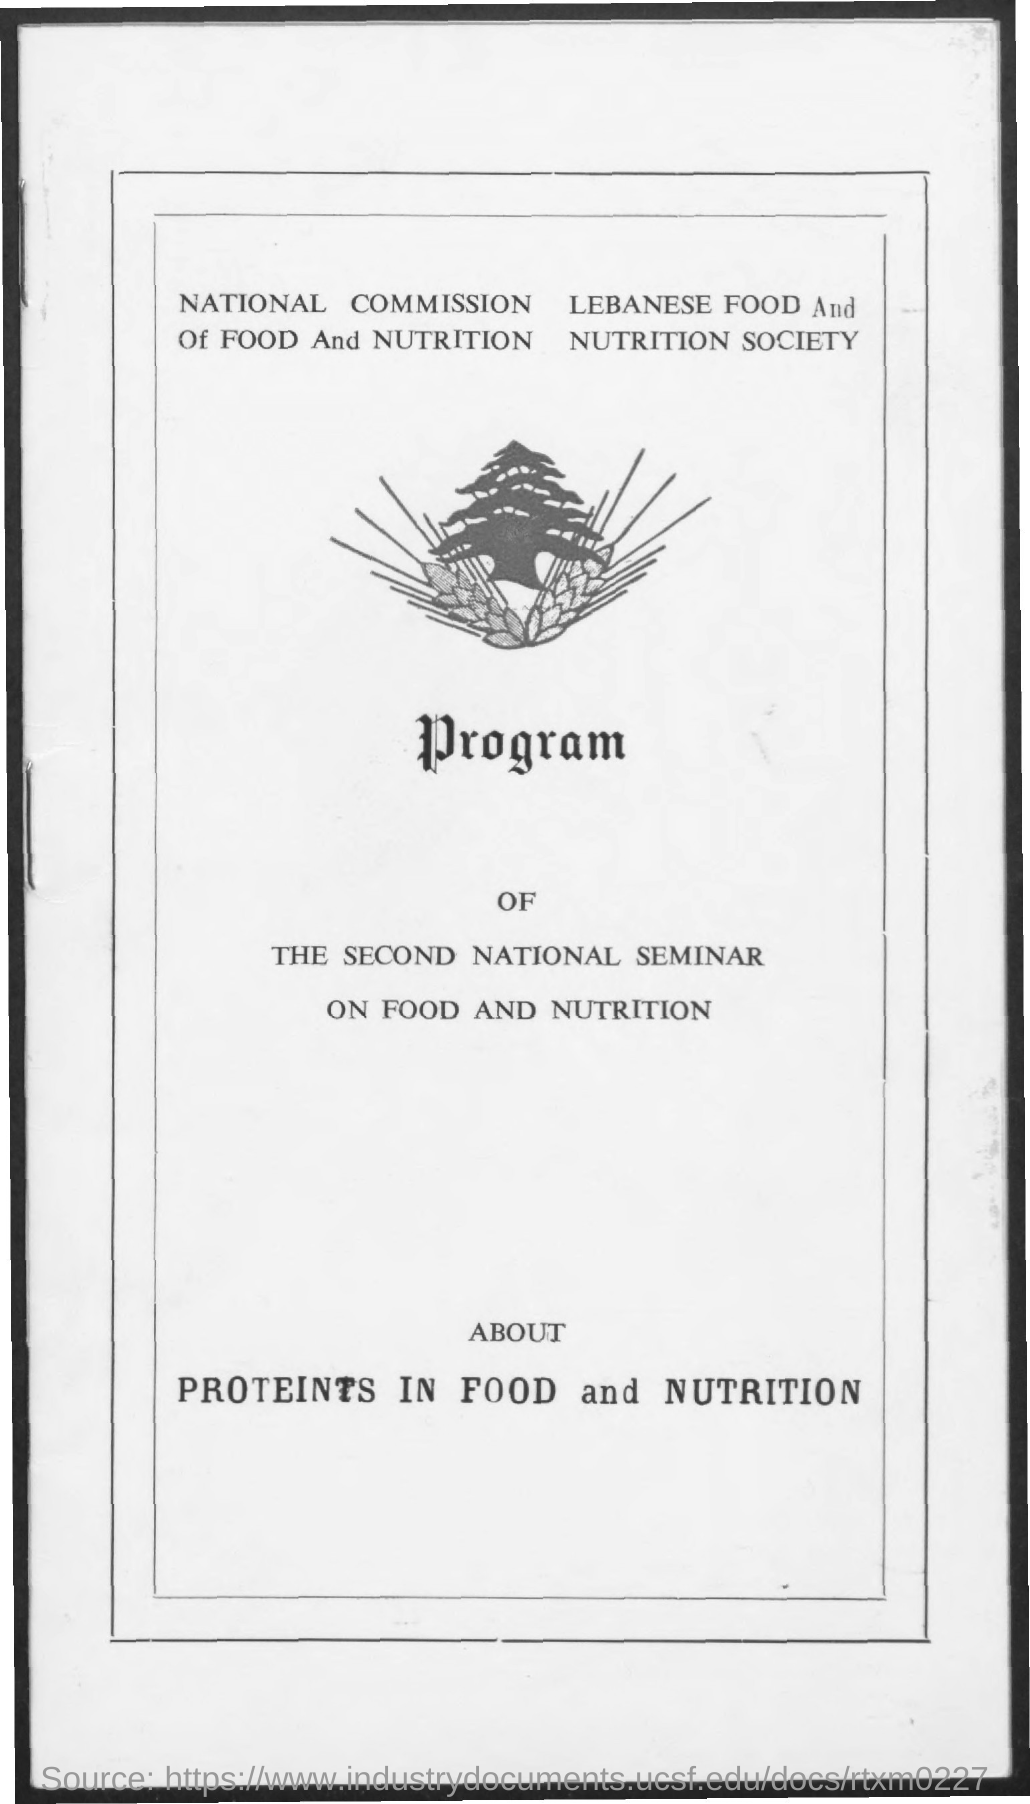The program is about which subject?
Offer a very short reply. Proteins in food and nutrition. What is the name of the society?
Provide a short and direct response. Lebanese Food and Nutrition Society. What is the name of the commission?
Make the answer very short. National Commission of Food and Nutrition. Which text is below the image?
Offer a very short reply. Program. 